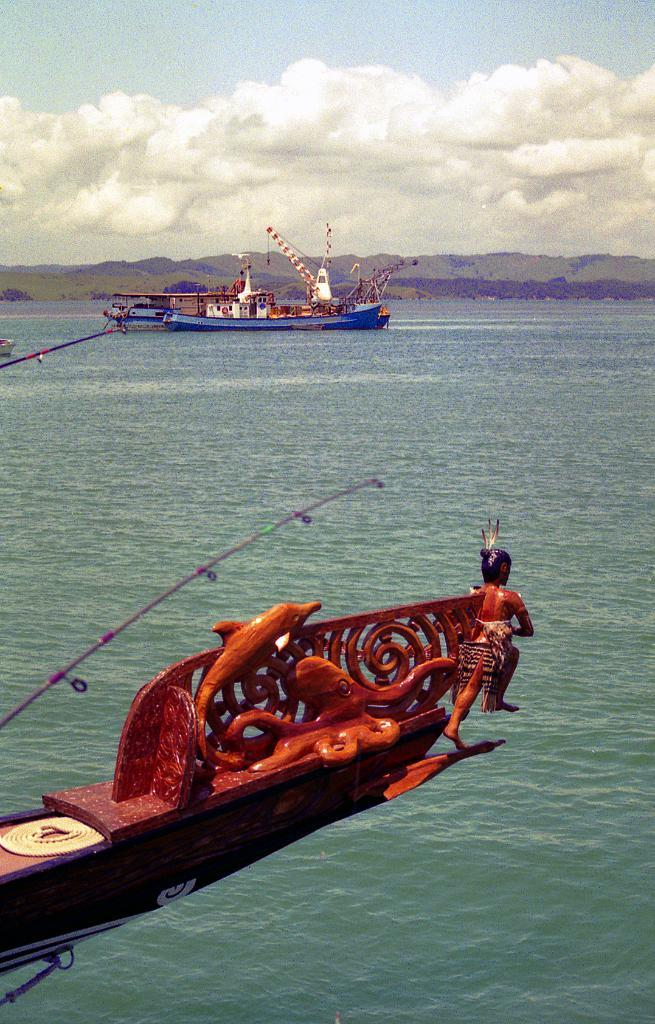What type of natural feature is visible in the image? There is a sea in the image. What else can be seen in the sea? There are water crafts in the image. How would you describe the sky in the image? The sky is blue and cloudy in the image. What type of land feature is visible in the image? There are hills in the image. What verse is being recited by the circle in the image? There is no circle or verse present in the image. 